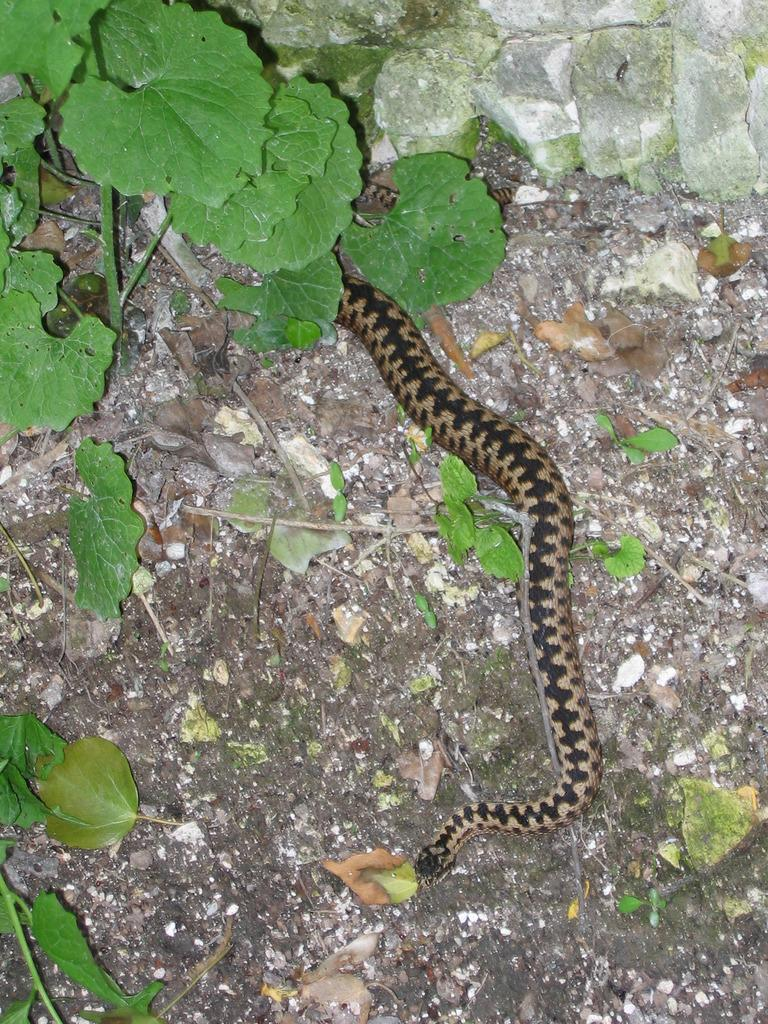What is on the ground in the image? There is a snake on the ground, along with leaves and a plant. What type of vegetation is present on the ground? There are leaves and a plant on the ground. What type of jeans is the creature wearing in the image? There is no creature or jeans present in the image; it features a snake, leaves, and a plant on the ground. 